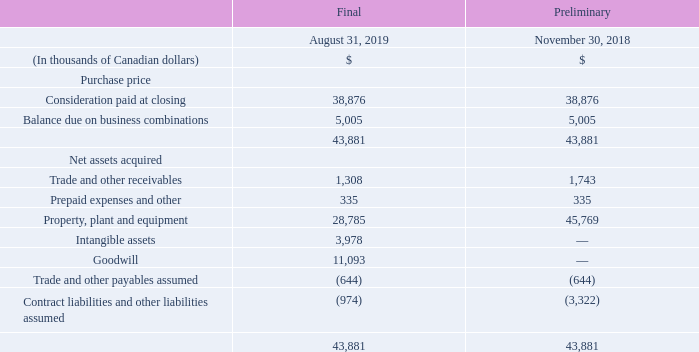BUSINESS COMBINATION IN FISCAL 2019
Purchase of a fibre network and corresponding assets
On October 3, 2018, the Corporation's subsidiary, Atlantic Broadband, completed the acquisition of the south Florida fibre network previously owned by FiberLight, LLC. The transaction, combined with the dark fibers acquired from FiberLight in the second quarter of fiscal 2018, added 350 route miles to Atlantic Broadband’s existing south Florida footprint.
The acquisition was accounted for using the purchase method and was subject to post closing adjustments. The final allocation of the purchase price of this acquisition is as follows:
When did Atlantic Broadband, completed the acquisition of the south Florida fibre network? October 3, 2018. Which company previously owned South Florida fibre network? Fiberlight, llc. Which company was acquired by Atlantic Broadband in 2018? South florida fibre network. What is the increase/ (decrease) in Trade and other receivables from Preliminary, November 30, 2018 to Final August 31, 2019?
Answer scale should be: thousand. 1,308-1,743
Answer: -435. What is the increase/ (decrease) in Property, plant and equipment from Preliminary, November 30, 2018 to Final August 31, 2019?
Answer scale should be: thousand. 28,785-45,769
Answer: -16984. What is the increase/ (decrease) in Contract liabilities and other liabilities assumed from Preliminary, November 30, 2018 to Final August 31, 2019?
Answer scale should be: thousand. (-974)-(-3,322)
Answer: 2348. 